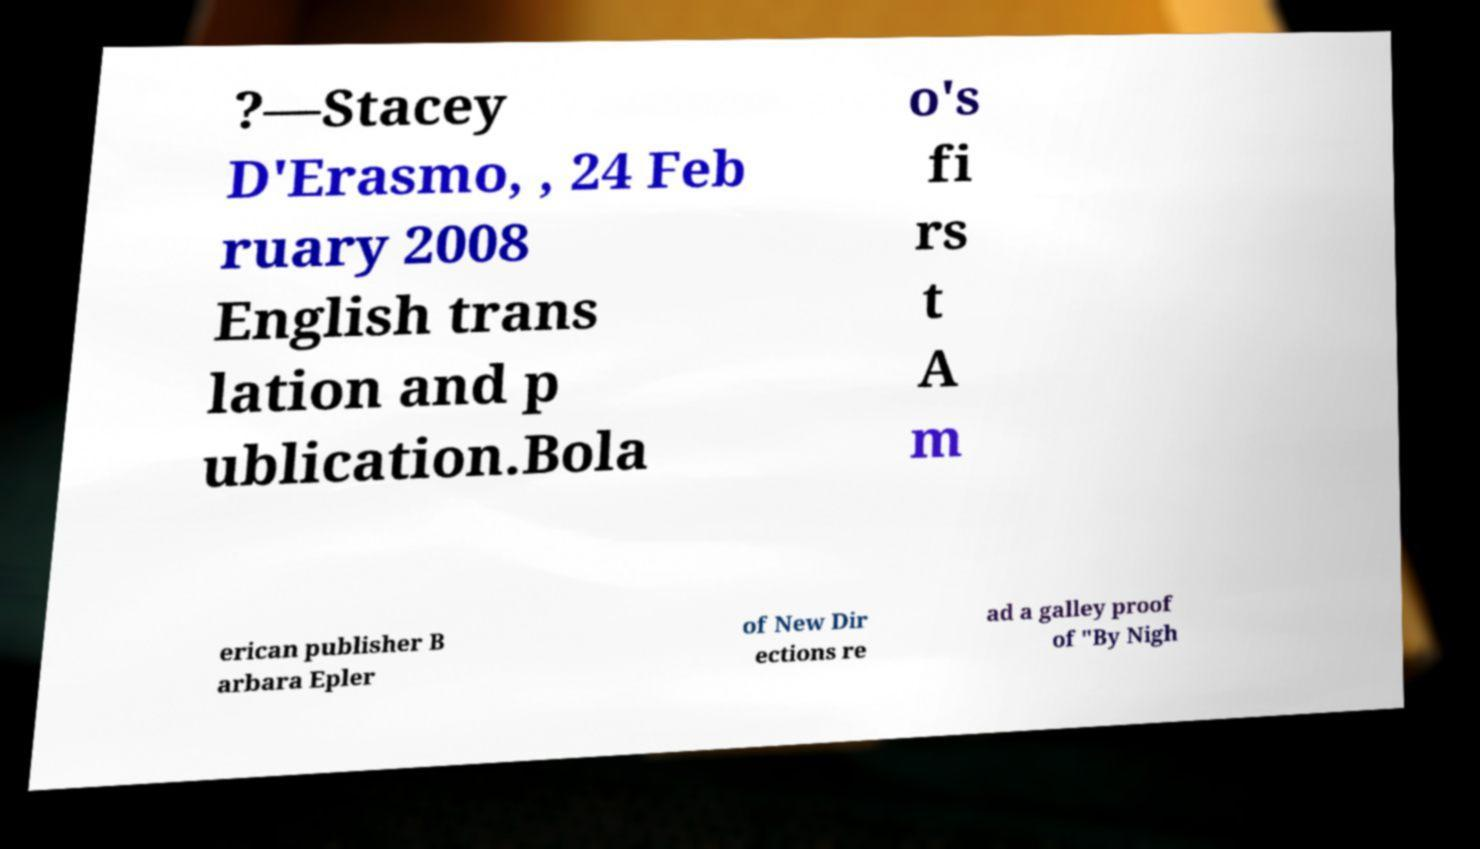Please read and relay the text visible in this image. What does it say? ?—Stacey D'Erasmo, , 24 Feb ruary 2008 English trans lation and p ublication.Bola o's fi rs t A m erican publisher B arbara Epler of New Dir ections re ad a galley proof of "By Nigh 